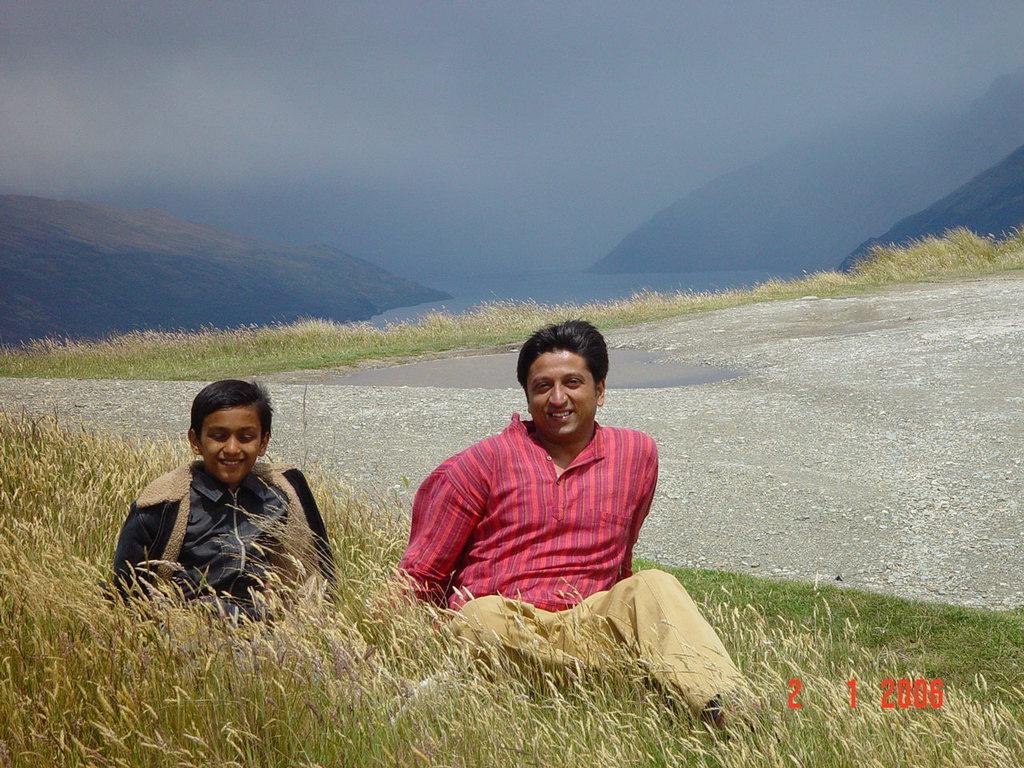Describe this image in one or two sentences. In this picture we can see a man and a boy sitting on the grass and smiling and at the back of him we can see the ground, mountains, sky. 